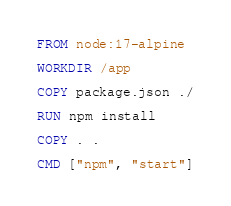Convert code to text. <code><loc_0><loc_0><loc_500><loc_500><_Dockerfile_>FROM node:17-alpine

WORKDIR /app

COPY package.json ./

RUN npm install

COPY . .

CMD ["npm", "start"]
</code> 